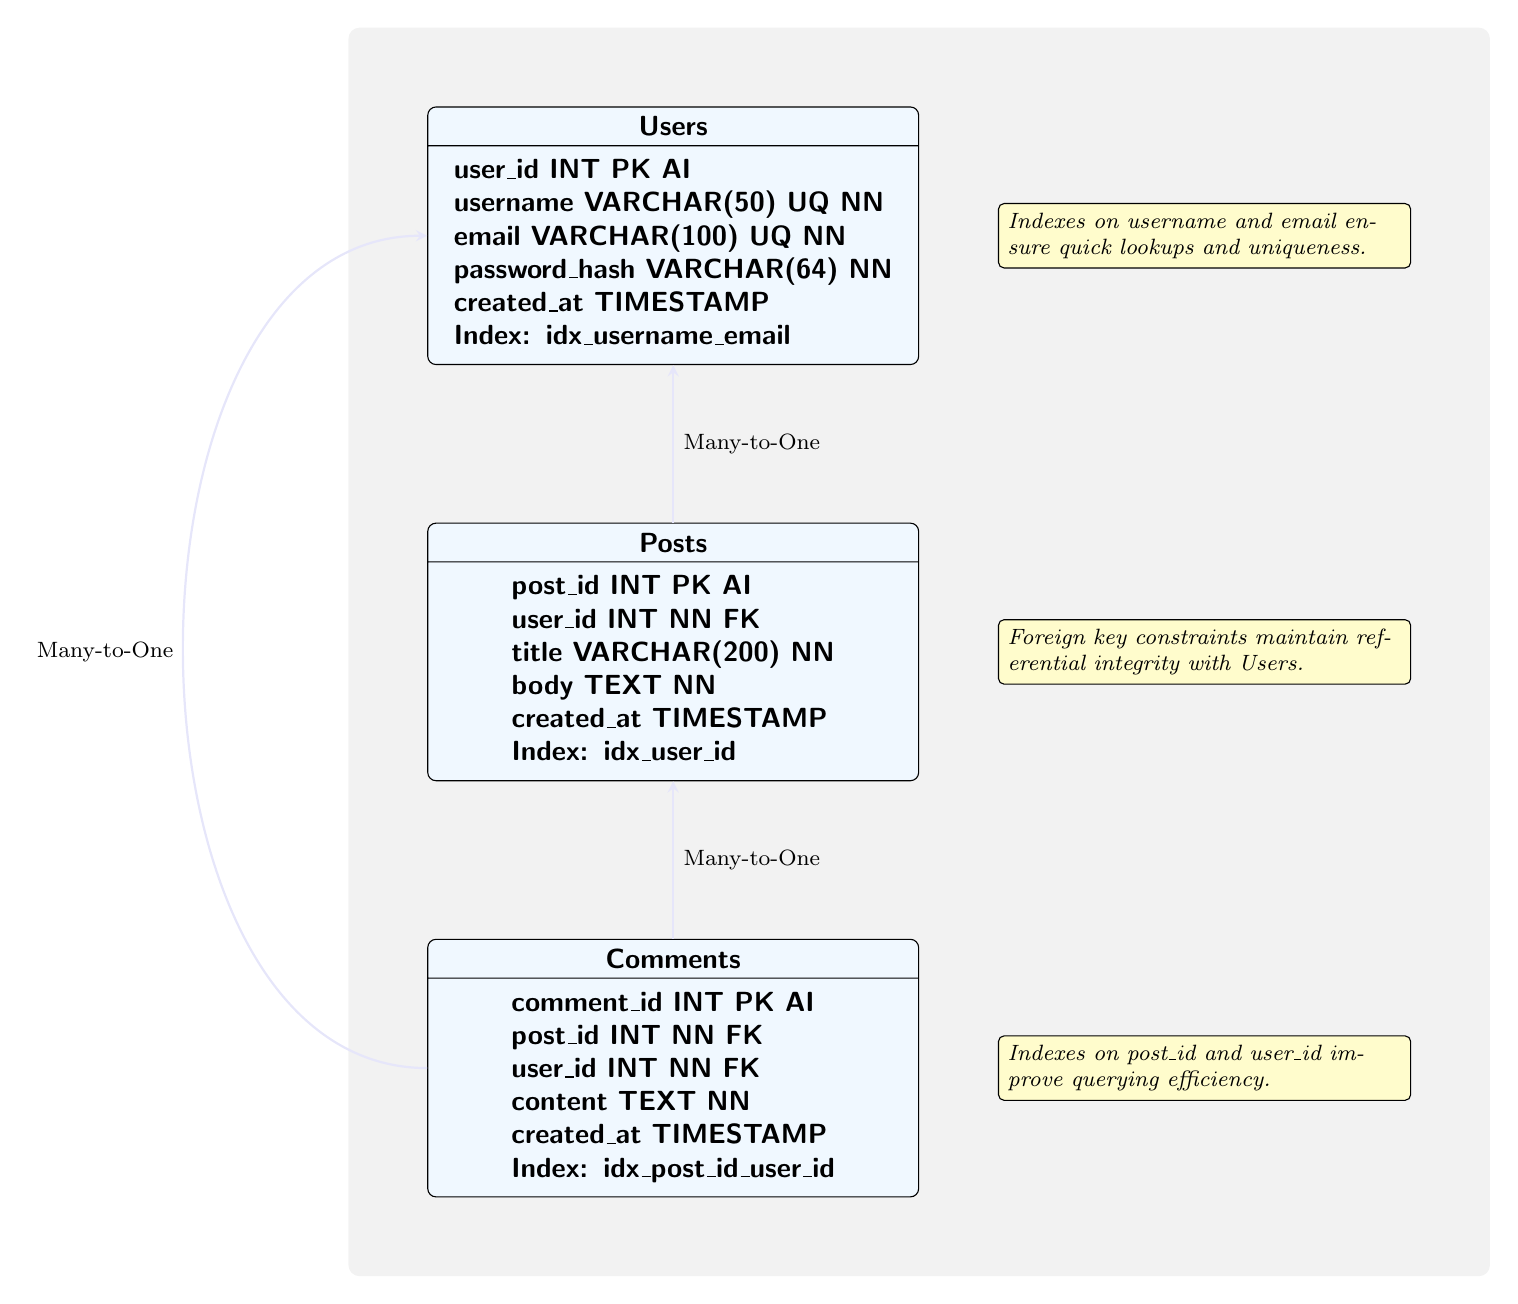What is the primary key of the Users table? The primary key of the Users table is specified as user_id, marked with PK in the diagram.
Answer: user_id How many tables are present in the diagram? The diagram shows three tables: Users, Posts, and Comments. Counting these gives a total of three tables.
Answer: 3 What is the foreign key in the Posts table? The foreign key in the Posts table is indicated as user_id, denoted by FK in the diagram.
Answer: user_id What type of relationship exists between Posts and Users? The relationship between Posts and Users is labeled as Many-to-One in the diagram.
Answer: Many-to-One What indexes are defined on the Comments table? The Comments table has an index specified as idx_post_id_user_id, which is indicated in the diagram.
Answer: idx_post_id_user_id Which note explains the optimization for the Users table? The note associated with the Users table mentions that indexes on username and email ensure quick lookups and uniqueness.
Answer: Indexes on username and email ensure quick lookups and uniqueness Why is the foreign key constraint important in the Posts table? The foreign key constraint in the Posts table ensures referential integrity with Users, meaning it maintains valid references to existing users.
Answer: It maintains referential integrity with Users How many indexes are listed in total across all tables? There are a total of three indexes mentioned: idx_username_email on the Users table, idx_user_id on the Posts table, and idx_post_id_user_id on the Comments table.
Answer: 3 What does the note associated with the Comments table highlight? The note for the Comments table emphasizes that indexes on post_id and user_id improve querying efficiency.
Answer: Indexes on post_id and user_id improve querying efficiency 